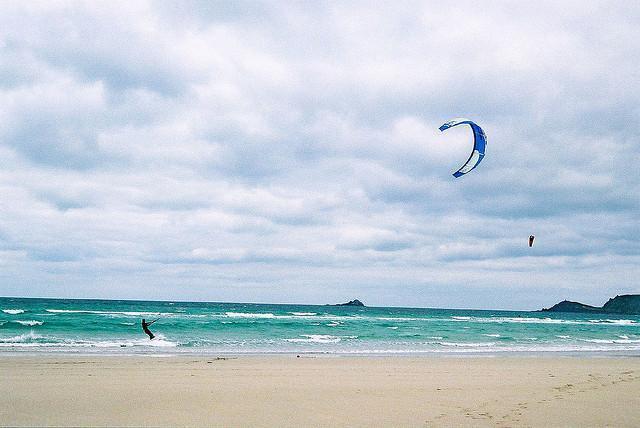How many boats are shown?
Give a very brief answer. 0. 